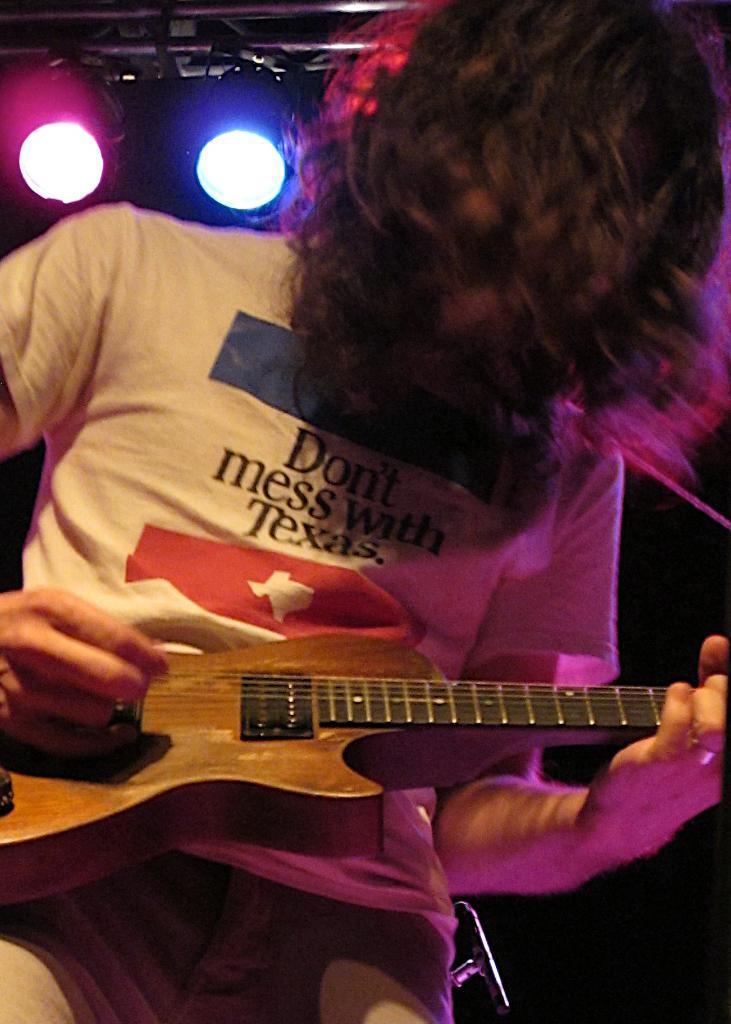Can you describe this image briefly? Here we can see a person with short hair playing guitar. At the top we can see lights. Background is dark. 